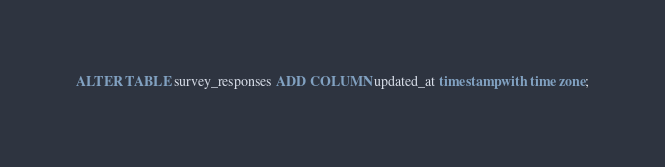Convert code to text. <code><loc_0><loc_0><loc_500><loc_500><_SQL_>ALTER TABLE survey_responses ADD COLUMN updated_at timestamp with time zone;</code> 